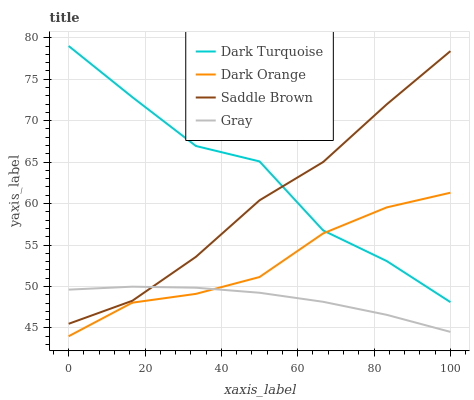Does Gray have the minimum area under the curve?
Answer yes or no. Yes. Does Dark Turquoise have the maximum area under the curve?
Answer yes or no. Yes. Does Saddle Brown have the minimum area under the curve?
Answer yes or no. No. Does Saddle Brown have the maximum area under the curve?
Answer yes or no. No. Is Gray the smoothest?
Answer yes or no. Yes. Is Dark Turquoise the roughest?
Answer yes or no. Yes. Is Saddle Brown the smoothest?
Answer yes or no. No. Is Saddle Brown the roughest?
Answer yes or no. No. Does Dark Orange have the lowest value?
Answer yes or no. Yes. Does Gray have the lowest value?
Answer yes or no. No. Does Dark Turquoise have the highest value?
Answer yes or no. Yes. Does Saddle Brown have the highest value?
Answer yes or no. No. Is Dark Orange less than Saddle Brown?
Answer yes or no. Yes. Is Saddle Brown greater than Dark Orange?
Answer yes or no. Yes. Does Dark Turquoise intersect Saddle Brown?
Answer yes or no. Yes. Is Dark Turquoise less than Saddle Brown?
Answer yes or no. No. Is Dark Turquoise greater than Saddle Brown?
Answer yes or no. No. Does Dark Orange intersect Saddle Brown?
Answer yes or no. No. 